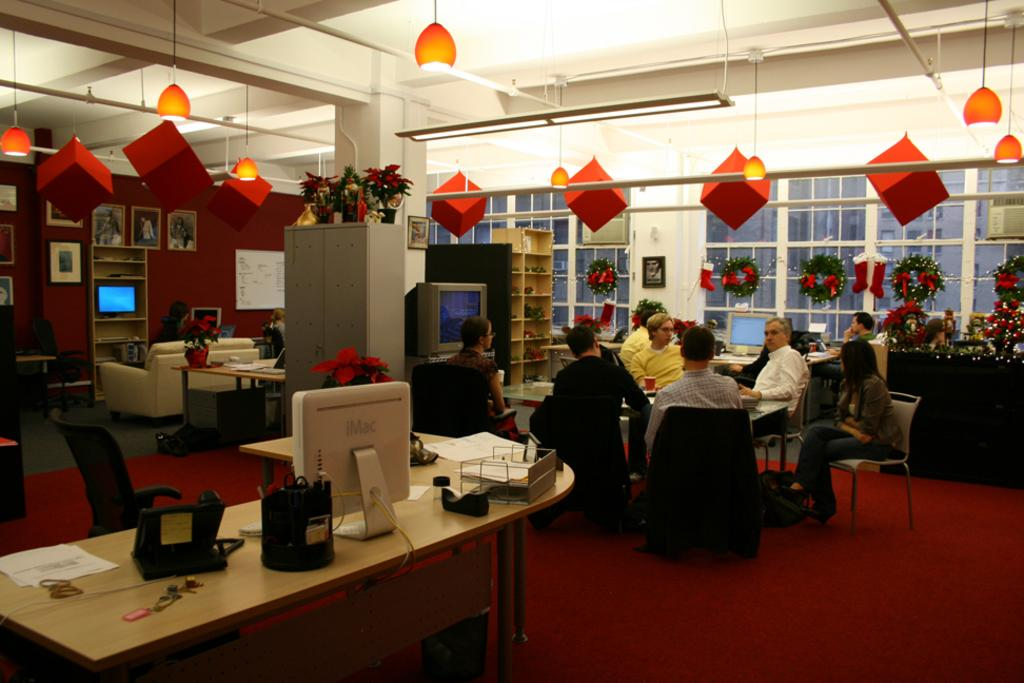What is the color of the wall in the image? The wall in the image is white. What can be seen on the wall in the image? There are windows on the wall in the image. What are the people in the image doing? The people in the image are sitting. What is on the table in the image? There is a screen and plants on the table in the image. What is the color of the floor in the image? The floor in the image is red. What type of calendar is hanging on the wall in the image? There is no calendar present in the image. What suggestion is being made by the people sitting in the image? The image does not provide any information about a suggestion being made by the people sitting. 